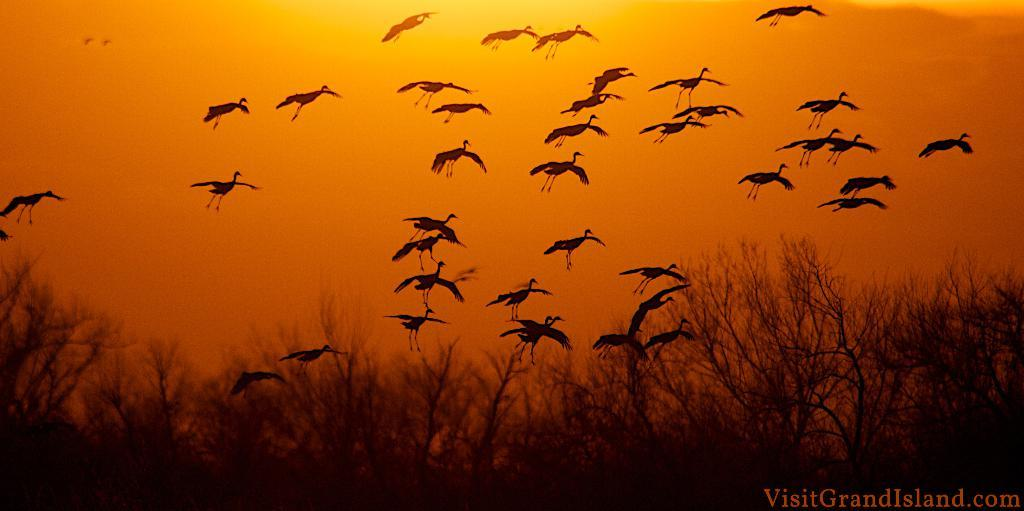What type of animals can be seen in the image? There are birds in the image. What other elements are present in the image besides the birds? There are plants and the sky visible in the image. What is the color of the sky in the image? The sky has a yellow and orange color in the image. Is there any indication of the image being a digital copy? Yes, there is a watermark in the image. Can you describe the acoustics of the girl's voice in the image? There is no girl present in the image, so it is not possible to describe the acoustics of her voice. What type of dog can be seen playing with the birds in the image? There are no dogs present in the image; it features birds and plants. 